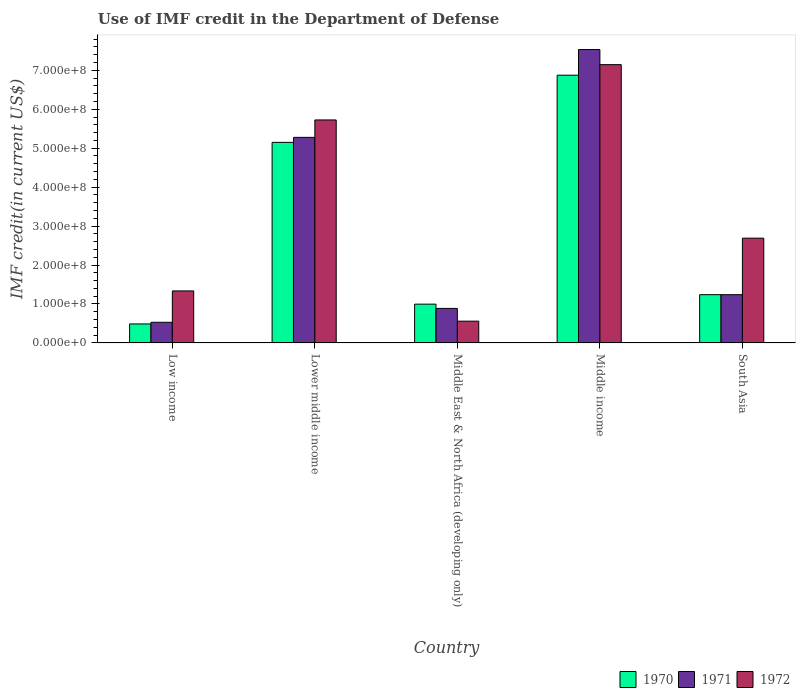How many groups of bars are there?
Your response must be concise. 5. Are the number of bars per tick equal to the number of legend labels?
Provide a succinct answer. Yes. Are the number of bars on each tick of the X-axis equal?
Keep it short and to the point. Yes. How many bars are there on the 2nd tick from the left?
Your answer should be compact. 3. What is the label of the 3rd group of bars from the left?
Provide a short and direct response. Middle East & North Africa (developing only). In how many cases, is the number of bars for a given country not equal to the number of legend labels?
Your response must be concise. 0. What is the IMF credit in the Department of Defense in 1972 in Middle income?
Provide a succinct answer. 7.14e+08. Across all countries, what is the maximum IMF credit in the Department of Defense in 1972?
Offer a terse response. 7.14e+08. Across all countries, what is the minimum IMF credit in the Department of Defense in 1970?
Keep it short and to the point. 4.88e+07. In which country was the IMF credit in the Department of Defense in 1972 minimum?
Provide a short and direct response. Middle East & North Africa (developing only). What is the total IMF credit in the Department of Defense in 1972 in the graph?
Ensure brevity in your answer.  1.75e+09. What is the difference between the IMF credit in the Department of Defense in 1970 in Low income and that in Middle East & North Africa (developing only)?
Offer a terse response. -5.08e+07. What is the difference between the IMF credit in the Department of Defense in 1971 in South Asia and the IMF credit in the Department of Defense in 1972 in Lower middle income?
Keep it short and to the point. -4.49e+08. What is the average IMF credit in the Department of Defense in 1971 per country?
Provide a short and direct response. 3.09e+08. What is the difference between the IMF credit in the Department of Defense of/in 1972 and IMF credit in the Department of Defense of/in 1971 in South Asia?
Make the answer very short. 1.45e+08. In how many countries, is the IMF credit in the Department of Defense in 1970 greater than 180000000 US$?
Provide a succinct answer. 2. What is the ratio of the IMF credit in the Department of Defense in 1970 in Low income to that in Middle East & North Africa (developing only)?
Your answer should be very brief. 0.49. Is the difference between the IMF credit in the Department of Defense in 1972 in Lower middle income and South Asia greater than the difference between the IMF credit in the Department of Defense in 1971 in Lower middle income and South Asia?
Ensure brevity in your answer.  No. What is the difference between the highest and the second highest IMF credit in the Department of Defense in 1970?
Give a very brief answer. 5.64e+08. What is the difference between the highest and the lowest IMF credit in the Department of Defense in 1971?
Provide a short and direct response. 7.00e+08. In how many countries, is the IMF credit in the Department of Defense in 1970 greater than the average IMF credit in the Department of Defense in 1970 taken over all countries?
Ensure brevity in your answer.  2. What does the 2nd bar from the left in South Asia represents?
Your answer should be compact. 1971. What does the 3rd bar from the right in Middle East & North Africa (developing only) represents?
Offer a terse response. 1970. Is it the case that in every country, the sum of the IMF credit in the Department of Defense in 1971 and IMF credit in the Department of Defense in 1970 is greater than the IMF credit in the Department of Defense in 1972?
Make the answer very short. No. Are all the bars in the graph horizontal?
Your answer should be compact. No. Does the graph contain grids?
Keep it short and to the point. No. Where does the legend appear in the graph?
Give a very brief answer. Bottom right. How many legend labels are there?
Offer a terse response. 3. How are the legend labels stacked?
Offer a very short reply. Horizontal. What is the title of the graph?
Provide a succinct answer. Use of IMF credit in the Department of Defense. Does "1994" appear as one of the legend labels in the graph?
Make the answer very short. No. What is the label or title of the Y-axis?
Provide a short and direct response. IMF credit(in current US$). What is the IMF credit(in current US$) in 1970 in Low income?
Ensure brevity in your answer.  4.88e+07. What is the IMF credit(in current US$) in 1971 in Low income?
Your answer should be very brief. 5.30e+07. What is the IMF credit(in current US$) in 1972 in Low income?
Provide a short and direct response. 1.34e+08. What is the IMF credit(in current US$) in 1970 in Lower middle income?
Your response must be concise. 5.15e+08. What is the IMF credit(in current US$) in 1971 in Lower middle income?
Offer a terse response. 5.28e+08. What is the IMF credit(in current US$) of 1972 in Lower middle income?
Give a very brief answer. 5.73e+08. What is the IMF credit(in current US$) of 1970 in Middle East & North Africa (developing only)?
Provide a succinct answer. 9.96e+07. What is the IMF credit(in current US$) of 1971 in Middle East & North Africa (developing only)?
Provide a short and direct response. 8.86e+07. What is the IMF credit(in current US$) of 1972 in Middle East & North Africa (developing only)?
Provide a short and direct response. 5.59e+07. What is the IMF credit(in current US$) in 1970 in Middle income?
Your answer should be very brief. 6.87e+08. What is the IMF credit(in current US$) of 1971 in Middle income?
Keep it short and to the point. 7.53e+08. What is the IMF credit(in current US$) in 1972 in Middle income?
Your response must be concise. 7.14e+08. What is the IMF credit(in current US$) in 1970 in South Asia?
Your answer should be compact. 1.24e+08. What is the IMF credit(in current US$) in 1971 in South Asia?
Provide a short and direct response. 1.24e+08. What is the IMF credit(in current US$) in 1972 in South Asia?
Provide a short and direct response. 2.69e+08. Across all countries, what is the maximum IMF credit(in current US$) of 1970?
Provide a short and direct response. 6.87e+08. Across all countries, what is the maximum IMF credit(in current US$) in 1971?
Provide a short and direct response. 7.53e+08. Across all countries, what is the maximum IMF credit(in current US$) in 1972?
Provide a short and direct response. 7.14e+08. Across all countries, what is the minimum IMF credit(in current US$) in 1970?
Offer a terse response. 4.88e+07. Across all countries, what is the minimum IMF credit(in current US$) of 1971?
Ensure brevity in your answer.  5.30e+07. Across all countries, what is the minimum IMF credit(in current US$) in 1972?
Offer a very short reply. 5.59e+07. What is the total IMF credit(in current US$) of 1970 in the graph?
Keep it short and to the point. 1.47e+09. What is the total IMF credit(in current US$) of 1971 in the graph?
Your answer should be compact. 1.55e+09. What is the total IMF credit(in current US$) in 1972 in the graph?
Ensure brevity in your answer.  1.75e+09. What is the difference between the IMF credit(in current US$) of 1970 in Low income and that in Lower middle income?
Make the answer very short. -4.66e+08. What is the difference between the IMF credit(in current US$) in 1971 in Low income and that in Lower middle income?
Provide a succinct answer. -4.75e+08. What is the difference between the IMF credit(in current US$) in 1972 in Low income and that in Lower middle income?
Make the answer very short. -4.39e+08. What is the difference between the IMF credit(in current US$) in 1970 in Low income and that in Middle East & North Africa (developing only)?
Your response must be concise. -5.08e+07. What is the difference between the IMF credit(in current US$) of 1971 in Low income and that in Middle East & North Africa (developing only)?
Your answer should be compact. -3.56e+07. What is the difference between the IMF credit(in current US$) in 1972 in Low income and that in Middle East & North Africa (developing only)?
Offer a terse response. 7.76e+07. What is the difference between the IMF credit(in current US$) in 1970 in Low income and that in Middle income?
Keep it short and to the point. -6.39e+08. What is the difference between the IMF credit(in current US$) in 1971 in Low income and that in Middle income?
Make the answer very short. -7.00e+08. What is the difference between the IMF credit(in current US$) of 1972 in Low income and that in Middle income?
Your answer should be very brief. -5.81e+08. What is the difference between the IMF credit(in current US$) in 1970 in Low income and that in South Asia?
Provide a short and direct response. -7.51e+07. What is the difference between the IMF credit(in current US$) in 1971 in Low income and that in South Asia?
Ensure brevity in your answer.  -7.09e+07. What is the difference between the IMF credit(in current US$) in 1972 in Low income and that in South Asia?
Provide a succinct answer. -1.35e+08. What is the difference between the IMF credit(in current US$) of 1970 in Lower middle income and that in Middle East & North Africa (developing only)?
Offer a terse response. 4.15e+08. What is the difference between the IMF credit(in current US$) in 1971 in Lower middle income and that in Middle East & North Africa (developing only)?
Your answer should be compact. 4.39e+08. What is the difference between the IMF credit(in current US$) in 1972 in Lower middle income and that in Middle East & North Africa (developing only)?
Provide a succinct answer. 5.17e+08. What is the difference between the IMF credit(in current US$) in 1970 in Lower middle income and that in Middle income?
Provide a short and direct response. -1.72e+08. What is the difference between the IMF credit(in current US$) of 1971 in Lower middle income and that in Middle income?
Keep it short and to the point. -2.25e+08. What is the difference between the IMF credit(in current US$) in 1972 in Lower middle income and that in Middle income?
Offer a very short reply. -1.42e+08. What is the difference between the IMF credit(in current US$) of 1970 in Lower middle income and that in South Asia?
Provide a short and direct response. 3.91e+08. What is the difference between the IMF credit(in current US$) of 1971 in Lower middle income and that in South Asia?
Offer a very short reply. 4.04e+08. What is the difference between the IMF credit(in current US$) in 1972 in Lower middle income and that in South Asia?
Your response must be concise. 3.04e+08. What is the difference between the IMF credit(in current US$) in 1970 in Middle East & North Africa (developing only) and that in Middle income?
Your answer should be compact. -5.88e+08. What is the difference between the IMF credit(in current US$) of 1971 in Middle East & North Africa (developing only) and that in Middle income?
Ensure brevity in your answer.  -6.65e+08. What is the difference between the IMF credit(in current US$) in 1972 in Middle East & North Africa (developing only) and that in Middle income?
Offer a very short reply. -6.59e+08. What is the difference between the IMF credit(in current US$) of 1970 in Middle East & North Africa (developing only) and that in South Asia?
Provide a short and direct response. -2.43e+07. What is the difference between the IMF credit(in current US$) of 1971 in Middle East & North Africa (developing only) and that in South Asia?
Provide a short and direct response. -3.53e+07. What is the difference between the IMF credit(in current US$) in 1972 in Middle East & North Africa (developing only) and that in South Asia?
Your response must be concise. -2.13e+08. What is the difference between the IMF credit(in current US$) in 1970 in Middle income and that in South Asia?
Your answer should be compact. 5.64e+08. What is the difference between the IMF credit(in current US$) of 1971 in Middle income and that in South Asia?
Keep it short and to the point. 6.29e+08. What is the difference between the IMF credit(in current US$) of 1972 in Middle income and that in South Asia?
Keep it short and to the point. 4.45e+08. What is the difference between the IMF credit(in current US$) of 1970 in Low income and the IMF credit(in current US$) of 1971 in Lower middle income?
Make the answer very short. -4.79e+08. What is the difference between the IMF credit(in current US$) of 1970 in Low income and the IMF credit(in current US$) of 1972 in Lower middle income?
Make the answer very short. -5.24e+08. What is the difference between the IMF credit(in current US$) of 1971 in Low income and the IMF credit(in current US$) of 1972 in Lower middle income?
Offer a very short reply. -5.20e+08. What is the difference between the IMF credit(in current US$) of 1970 in Low income and the IMF credit(in current US$) of 1971 in Middle East & North Africa (developing only)?
Offer a very short reply. -3.98e+07. What is the difference between the IMF credit(in current US$) in 1970 in Low income and the IMF credit(in current US$) in 1972 in Middle East & North Africa (developing only)?
Your answer should be compact. -7.12e+06. What is the difference between the IMF credit(in current US$) of 1971 in Low income and the IMF credit(in current US$) of 1972 in Middle East & North Africa (developing only)?
Give a very brief answer. -2.90e+06. What is the difference between the IMF credit(in current US$) of 1970 in Low income and the IMF credit(in current US$) of 1971 in Middle income?
Your answer should be very brief. -7.04e+08. What is the difference between the IMF credit(in current US$) of 1970 in Low income and the IMF credit(in current US$) of 1972 in Middle income?
Ensure brevity in your answer.  -6.66e+08. What is the difference between the IMF credit(in current US$) in 1971 in Low income and the IMF credit(in current US$) in 1972 in Middle income?
Your answer should be very brief. -6.61e+08. What is the difference between the IMF credit(in current US$) in 1970 in Low income and the IMF credit(in current US$) in 1971 in South Asia?
Provide a succinct answer. -7.51e+07. What is the difference between the IMF credit(in current US$) of 1970 in Low income and the IMF credit(in current US$) of 1972 in South Asia?
Offer a terse response. -2.20e+08. What is the difference between the IMF credit(in current US$) of 1971 in Low income and the IMF credit(in current US$) of 1972 in South Asia?
Give a very brief answer. -2.16e+08. What is the difference between the IMF credit(in current US$) in 1970 in Lower middle income and the IMF credit(in current US$) in 1971 in Middle East & North Africa (developing only)?
Give a very brief answer. 4.26e+08. What is the difference between the IMF credit(in current US$) in 1970 in Lower middle income and the IMF credit(in current US$) in 1972 in Middle East & North Africa (developing only)?
Provide a short and direct response. 4.59e+08. What is the difference between the IMF credit(in current US$) in 1971 in Lower middle income and the IMF credit(in current US$) in 1972 in Middle East & North Africa (developing only)?
Your response must be concise. 4.72e+08. What is the difference between the IMF credit(in current US$) in 1970 in Lower middle income and the IMF credit(in current US$) in 1971 in Middle income?
Offer a very short reply. -2.38e+08. What is the difference between the IMF credit(in current US$) of 1970 in Lower middle income and the IMF credit(in current US$) of 1972 in Middle income?
Offer a terse response. -2.00e+08. What is the difference between the IMF credit(in current US$) in 1971 in Lower middle income and the IMF credit(in current US$) in 1972 in Middle income?
Your answer should be compact. -1.87e+08. What is the difference between the IMF credit(in current US$) in 1970 in Lower middle income and the IMF credit(in current US$) in 1971 in South Asia?
Make the answer very short. 3.91e+08. What is the difference between the IMF credit(in current US$) of 1970 in Lower middle income and the IMF credit(in current US$) of 1972 in South Asia?
Your response must be concise. 2.46e+08. What is the difference between the IMF credit(in current US$) in 1971 in Lower middle income and the IMF credit(in current US$) in 1972 in South Asia?
Provide a succinct answer. 2.59e+08. What is the difference between the IMF credit(in current US$) in 1970 in Middle East & North Africa (developing only) and the IMF credit(in current US$) in 1971 in Middle income?
Provide a succinct answer. -6.54e+08. What is the difference between the IMF credit(in current US$) of 1970 in Middle East & North Africa (developing only) and the IMF credit(in current US$) of 1972 in Middle income?
Make the answer very short. -6.15e+08. What is the difference between the IMF credit(in current US$) of 1971 in Middle East & North Africa (developing only) and the IMF credit(in current US$) of 1972 in Middle income?
Your answer should be compact. -6.26e+08. What is the difference between the IMF credit(in current US$) in 1970 in Middle East & North Africa (developing only) and the IMF credit(in current US$) in 1971 in South Asia?
Your answer should be compact. -2.43e+07. What is the difference between the IMF credit(in current US$) of 1970 in Middle East & North Africa (developing only) and the IMF credit(in current US$) of 1972 in South Asia?
Provide a succinct answer. -1.69e+08. What is the difference between the IMF credit(in current US$) of 1971 in Middle East & North Africa (developing only) and the IMF credit(in current US$) of 1972 in South Asia?
Provide a succinct answer. -1.80e+08. What is the difference between the IMF credit(in current US$) in 1970 in Middle income and the IMF credit(in current US$) in 1971 in South Asia?
Make the answer very short. 5.64e+08. What is the difference between the IMF credit(in current US$) of 1970 in Middle income and the IMF credit(in current US$) of 1972 in South Asia?
Your response must be concise. 4.18e+08. What is the difference between the IMF credit(in current US$) of 1971 in Middle income and the IMF credit(in current US$) of 1972 in South Asia?
Your response must be concise. 4.84e+08. What is the average IMF credit(in current US$) in 1970 per country?
Offer a very short reply. 2.95e+08. What is the average IMF credit(in current US$) in 1971 per country?
Give a very brief answer. 3.09e+08. What is the average IMF credit(in current US$) in 1972 per country?
Offer a very short reply. 3.49e+08. What is the difference between the IMF credit(in current US$) in 1970 and IMF credit(in current US$) in 1971 in Low income?
Keep it short and to the point. -4.21e+06. What is the difference between the IMF credit(in current US$) in 1970 and IMF credit(in current US$) in 1972 in Low income?
Make the answer very short. -8.47e+07. What is the difference between the IMF credit(in current US$) of 1971 and IMF credit(in current US$) of 1972 in Low income?
Your answer should be compact. -8.05e+07. What is the difference between the IMF credit(in current US$) of 1970 and IMF credit(in current US$) of 1971 in Lower middle income?
Provide a succinct answer. -1.28e+07. What is the difference between the IMF credit(in current US$) in 1970 and IMF credit(in current US$) in 1972 in Lower middle income?
Make the answer very short. -5.76e+07. What is the difference between the IMF credit(in current US$) in 1971 and IMF credit(in current US$) in 1972 in Lower middle income?
Your answer should be very brief. -4.48e+07. What is the difference between the IMF credit(in current US$) of 1970 and IMF credit(in current US$) of 1971 in Middle East & North Africa (developing only)?
Provide a succinct answer. 1.10e+07. What is the difference between the IMF credit(in current US$) in 1970 and IMF credit(in current US$) in 1972 in Middle East & North Africa (developing only)?
Your answer should be very brief. 4.37e+07. What is the difference between the IMF credit(in current US$) in 1971 and IMF credit(in current US$) in 1972 in Middle East & North Africa (developing only)?
Your answer should be very brief. 3.27e+07. What is the difference between the IMF credit(in current US$) in 1970 and IMF credit(in current US$) in 1971 in Middle income?
Ensure brevity in your answer.  -6.58e+07. What is the difference between the IMF credit(in current US$) in 1970 and IMF credit(in current US$) in 1972 in Middle income?
Offer a very short reply. -2.71e+07. What is the difference between the IMF credit(in current US$) of 1971 and IMF credit(in current US$) of 1972 in Middle income?
Make the answer very short. 3.88e+07. What is the difference between the IMF credit(in current US$) of 1970 and IMF credit(in current US$) of 1972 in South Asia?
Provide a succinct answer. -1.45e+08. What is the difference between the IMF credit(in current US$) of 1971 and IMF credit(in current US$) of 1972 in South Asia?
Provide a short and direct response. -1.45e+08. What is the ratio of the IMF credit(in current US$) in 1970 in Low income to that in Lower middle income?
Offer a terse response. 0.09. What is the ratio of the IMF credit(in current US$) in 1971 in Low income to that in Lower middle income?
Provide a succinct answer. 0.1. What is the ratio of the IMF credit(in current US$) of 1972 in Low income to that in Lower middle income?
Your answer should be very brief. 0.23. What is the ratio of the IMF credit(in current US$) of 1970 in Low income to that in Middle East & North Africa (developing only)?
Make the answer very short. 0.49. What is the ratio of the IMF credit(in current US$) in 1971 in Low income to that in Middle East & North Africa (developing only)?
Provide a succinct answer. 0.6. What is the ratio of the IMF credit(in current US$) of 1972 in Low income to that in Middle East & North Africa (developing only)?
Offer a very short reply. 2.39. What is the ratio of the IMF credit(in current US$) of 1970 in Low income to that in Middle income?
Your response must be concise. 0.07. What is the ratio of the IMF credit(in current US$) of 1971 in Low income to that in Middle income?
Your answer should be compact. 0.07. What is the ratio of the IMF credit(in current US$) of 1972 in Low income to that in Middle income?
Give a very brief answer. 0.19. What is the ratio of the IMF credit(in current US$) of 1970 in Low income to that in South Asia?
Give a very brief answer. 0.39. What is the ratio of the IMF credit(in current US$) of 1971 in Low income to that in South Asia?
Provide a short and direct response. 0.43. What is the ratio of the IMF credit(in current US$) in 1972 in Low income to that in South Asia?
Make the answer very short. 0.5. What is the ratio of the IMF credit(in current US$) in 1970 in Lower middle income to that in Middle East & North Africa (developing only)?
Give a very brief answer. 5.17. What is the ratio of the IMF credit(in current US$) of 1971 in Lower middle income to that in Middle East & North Africa (developing only)?
Provide a succinct answer. 5.95. What is the ratio of the IMF credit(in current US$) in 1972 in Lower middle income to that in Middle East & North Africa (developing only)?
Provide a succinct answer. 10.24. What is the ratio of the IMF credit(in current US$) in 1970 in Lower middle income to that in Middle income?
Your answer should be compact. 0.75. What is the ratio of the IMF credit(in current US$) in 1971 in Lower middle income to that in Middle income?
Ensure brevity in your answer.  0.7. What is the ratio of the IMF credit(in current US$) of 1972 in Lower middle income to that in Middle income?
Offer a very short reply. 0.8. What is the ratio of the IMF credit(in current US$) in 1970 in Lower middle income to that in South Asia?
Make the answer very short. 4.16. What is the ratio of the IMF credit(in current US$) in 1971 in Lower middle income to that in South Asia?
Offer a very short reply. 4.26. What is the ratio of the IMF credit(in current US$) in 1972 in Lower middle income to that in South Asia?
Provide a succinct answer. 2.13. What is the ratio of the IMF credit(in current US$) in 1970 in Middle East & North Africa (developing only) to that in Middle income?
Give a very brief answer. 0.14. What is the ratio of the IMF credit(in current US$) in 1971 in Middle East & North Africa (developing only) to that in Middle income?
Ensure brevity in your answer.  0.12. What is the ratio of the IMF credit(in current US$) of 1972 in Middle East & North Africa (developing only) to that in Middle income?
Ensure brevity in your answer.  0.08. What is the ratio of the IMF credit(in current US$) in 1970 in Middle East & North Africa (developing only) to that in South Asia?
Offer a very short reply. 0.8. What is the ratio of the IMF credit(in current US$) in 1971 in Middle East & North Africa (developing only) to that in South Asia?
Keep it short and to the point. 0.72. What is the ratio of the IMF credit(in current US$) in 1972 in Middle East & North Africa (developing only) to that in South Asia?
Provide a short and direct response. 0.21. What is the ratio of the IMF credit(in current US$) of 1970 in Middle income to that in South Asia?
Your response must be concise. 5.55. What is the ratio of the IMF credit(in current US$) in 1971 in Middle income to that in South Asia?
Your response must be concise. 6.08. What is the ratio of the IMF credit(in current US$) of 1972 in Middle income to that in South Asia?
Make the answer very short. 2.66. What is the difference between the highest and the second highest IMF credit(in current US$) of 1970?
Your answer should be compact. 1.72e+08. What is the difference between the highest and the second highest IMF credit(in current US$) in 1971?
Your answer should be compact. 2.25e+08. What is the difference between the highest and the second highest IMF credit(in current US$) in 1972?
Offer a very short reply. 1.42e+08. What is the difference between the highest and the lowest IMF credit(in current US$) in 1970?
Give a very brief answer. 6.39e+08. What is the difference between the highest and the lowest IMF credit(in current US$) in 1971?
Offer a terse response. 7.00e+08. What is the difference between the highest and the lowest IMF credit(in current US$) in 1972?
Offer a very short reply. 6.59e+08. 